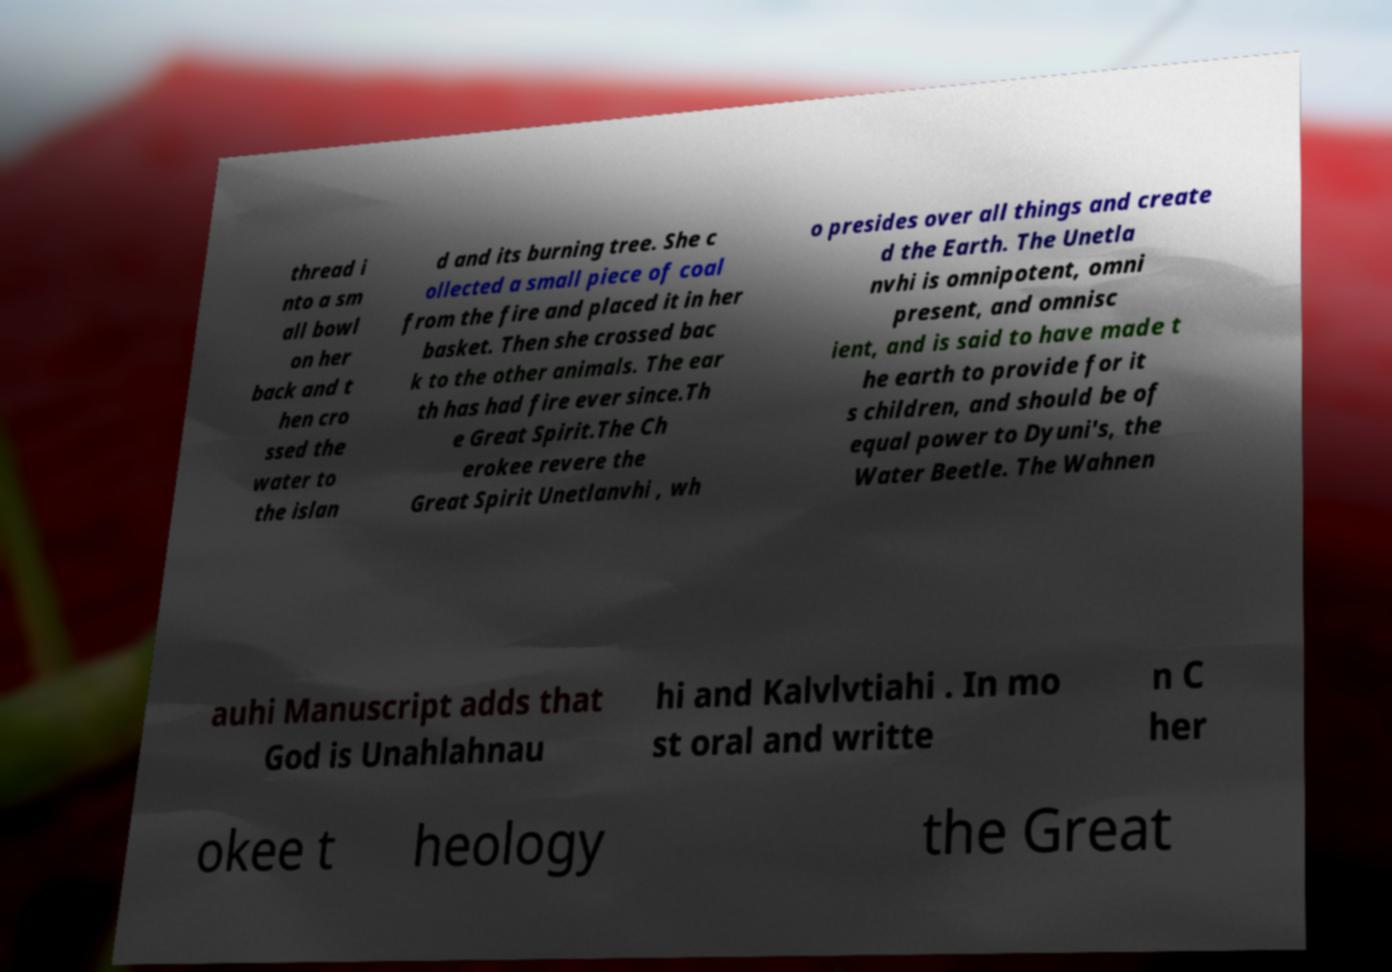I need the written content from this picture converted into text. Can you do that? thread i nto a sm all bowl on her back and t hen cro ssed the water to the islan d and its burning tree. She c ollected a small piece of coal from the fire and placed it in her basket. Then she crossed bac k to the other animals. The ear th has had fire ever since.Th e Great Spirit.The Ch erokee revere the Great Spirit Unetlanvhi , wh o presides over all things and create d the Earth. The Unetla nvhi is omnipotent, omni present, and omnisc ient, and is said to have made t he earth to provide for it s children, and should be of equal power to Dyuni's, the Water Beetle. The Wahnen auhi Manuscript adds that God is Unahlahnau hi and Kalvlvtiahi . In mo st oral and writte n C her okee t heology the Great 